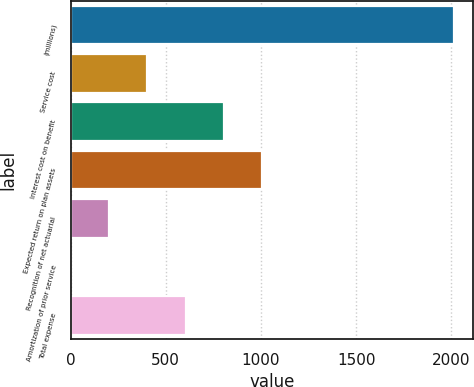<chart> <loc_0><loc_0><loc_500><loc_500><bar_chart><fcel>(millions)<fcel>Service cost<fcel>Interest cost on benefit<fcel>Expected return on plan assets<fcel>Recognition of net actuarial<fcel>Amortization of prior service<fcel>Total expense<nl><fcel>2014<fcel>403.12<fcel>805.84<fcel>1007.2<fcel>201.76<fcel>0.4<fcel>604.48<nl></chart> 